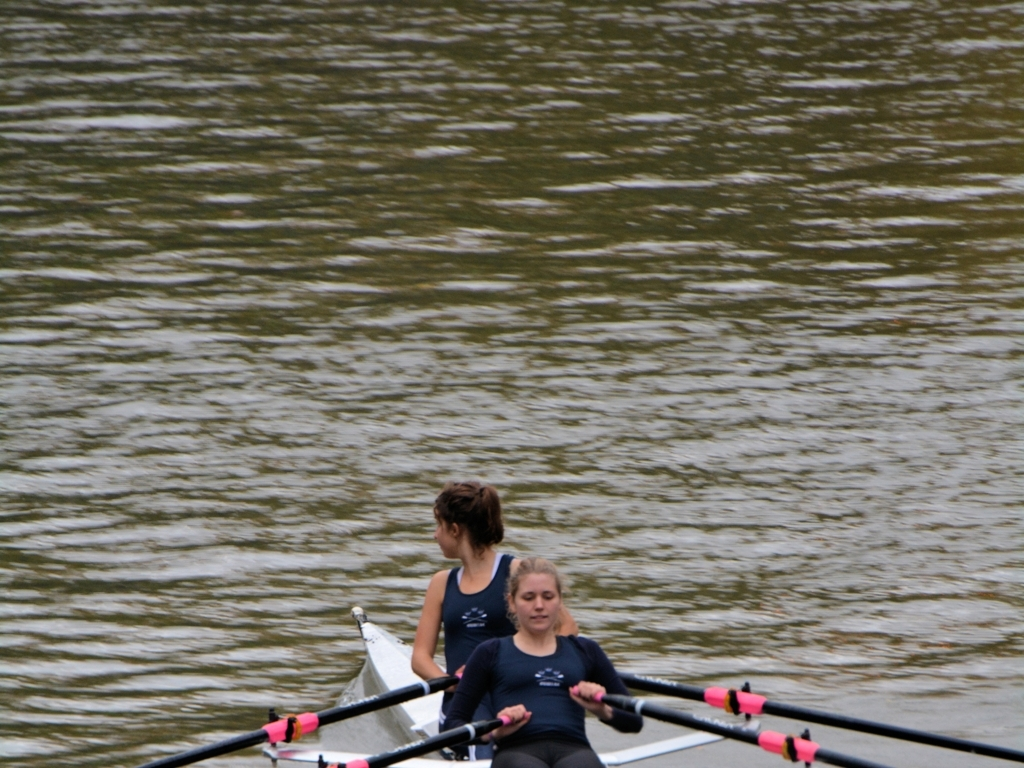Can you describe the technique shown by the rowers in this image? Are they using proper form? The rowers in the image are demonstrating a common rowing technique, where they maintain an upright posture with their backs straight and shoulder level. The rower in the front shows proper oar handling, keeping her wrists flat and oars parallel to the water, indicative of good technique. There might be slight room for improvement in synchronizing their strokes better to maximize efficiency. What adjustments could they make to improve their performance? Improving their stroke synchronization could enhance their rowing efficiency, allowing them to move faster with less effort. Additionally, focusing on a consistent rowing cadence and power application during each stroke would ensure smoother and more effective movement through the water. 